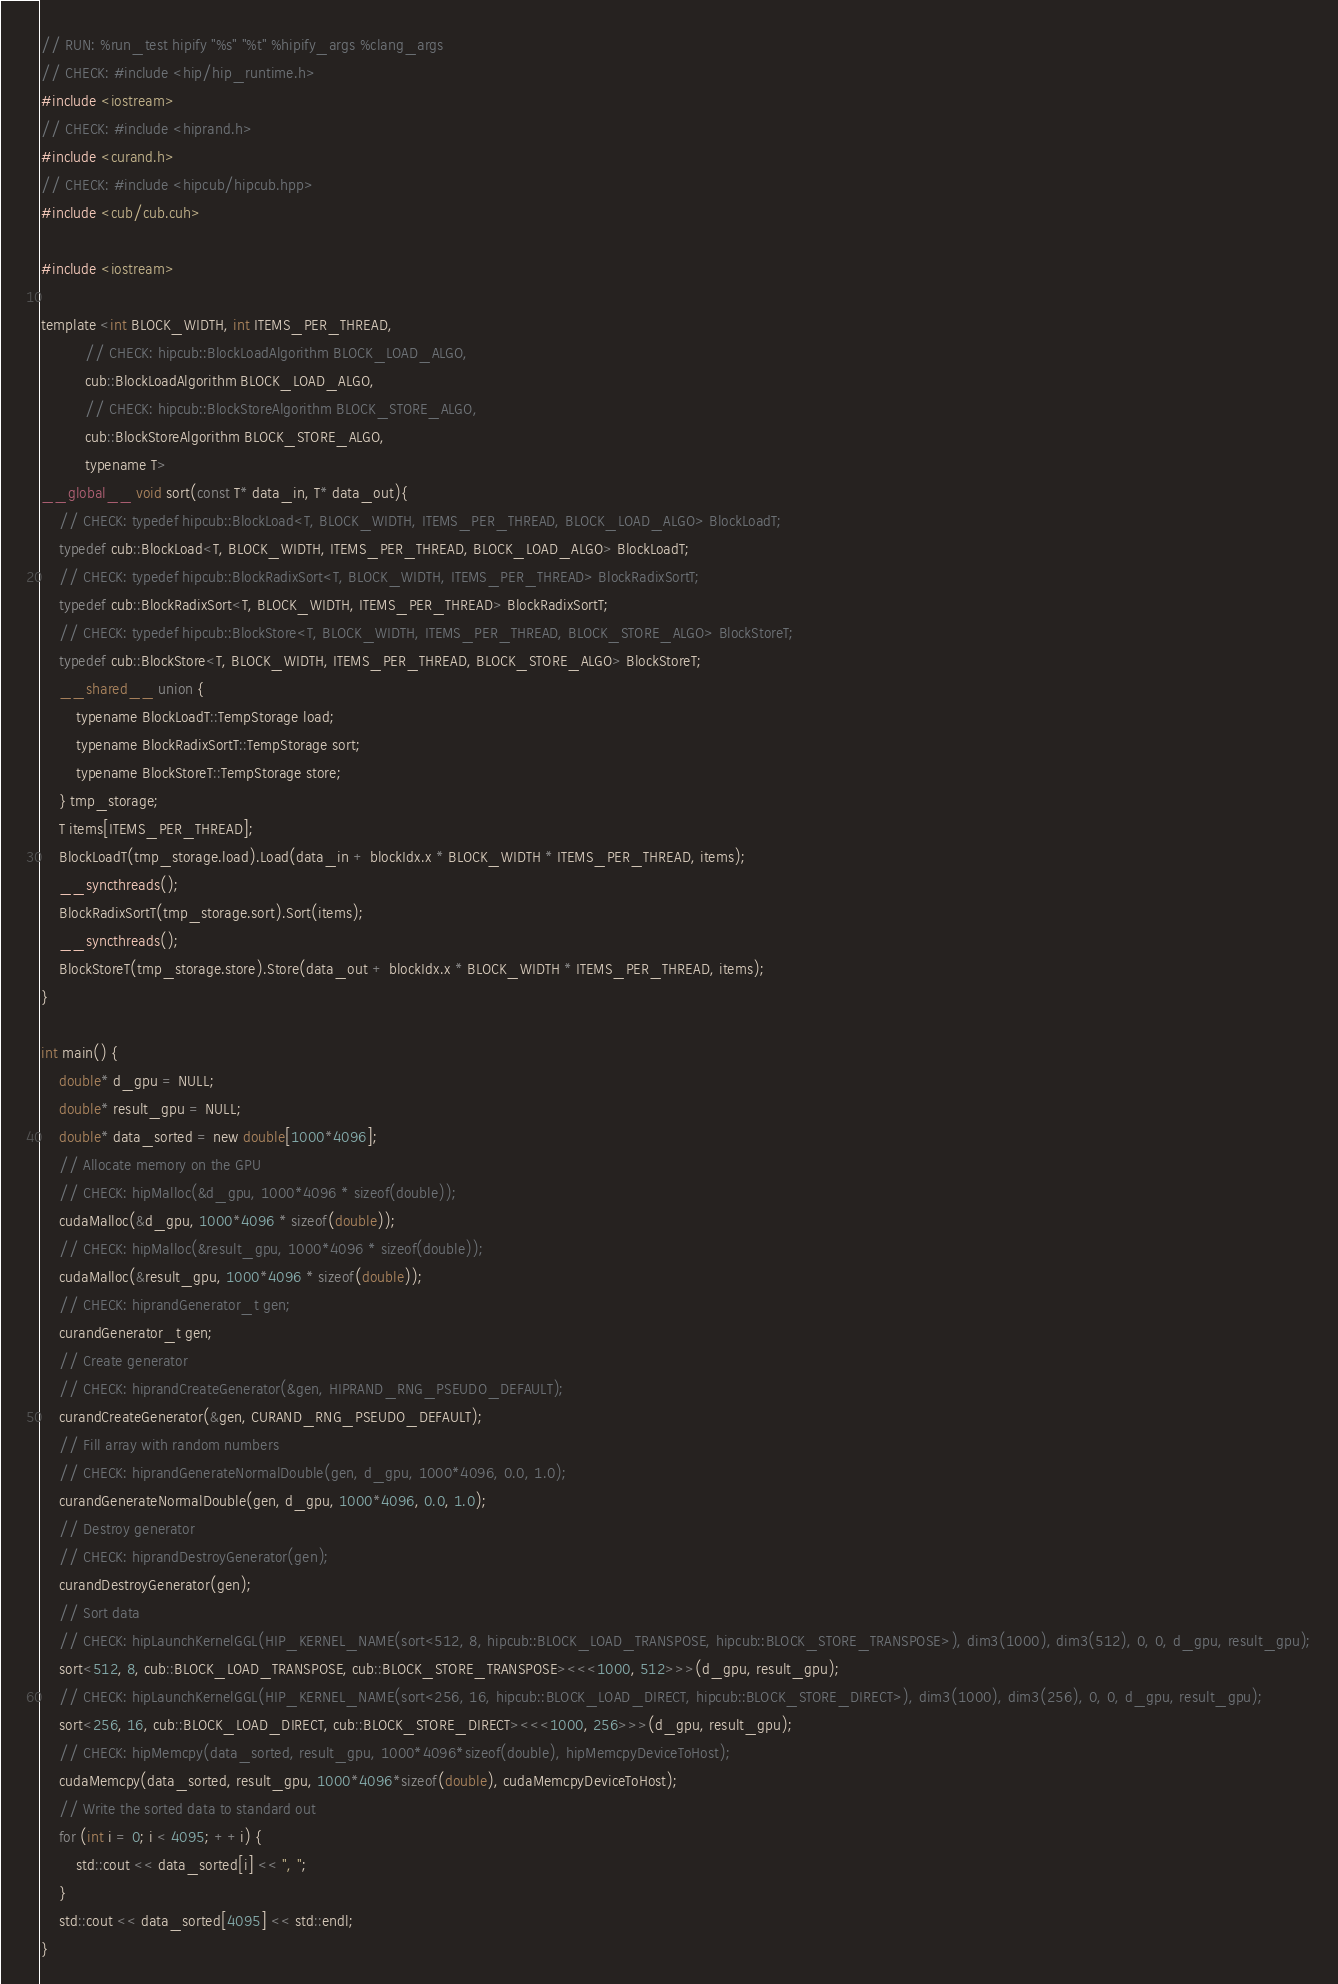<code> <loc_0><loc_0><loc_500><loc_500><_Cuda_>// RUN: %run_test hipify "%s" "%t" %hipify_args %clang_args
// CHECK: #include <hip/hip_runtime.h>
#include <iostream>
// CHECK: #include <hiprand.h>
#include <curand.h>
// CHECK: #include <hipcub/hipcub.hpp>
#include <cub/cub.cuh>

#include <iostream>

template <int BLOCK_WIDTH, int ITEMS_PER_THREAD,
          // CHECK: hipcub::BlockLoadAlgorithm BLOCK_LOAD_ALGO,
          cub::BlockLoadAlgorithm BLOCK_LOAD_ALGO,
          // CHECK: hipcub::BlockStoreAlgorithm BLOCK_STORE_ALGO,
          cub::BlockStoreAlgorithm BLOCK_STORE_ALGO,
          typename T>
__global__ void sort(const T* data_in, T* data_out){
    // CHECK: typedef hipcub::BlockLoad<T, BLOCK_WIDTH, ITEMS_PER_THREAD, BLOCK_LOAD_ALGO> BlockLoadT;
    typedef cub::BlockLoad<T, BLOCK_WIDTH, ITEMS_PER_THREAD, BLOCK_LOAD_ALGO> BlockLoadT;
    // CHECK: typedef hipcub::BlockRadixSort<T, BLOCK_WIDTH, ITEMS_PER_THREAD> BlockRadixSortT;
    typedef cub::BlockRadixSort<T, BLOCK_WIDTH, ITEMS_PER_THREAD> BlockRadixSortT;
    // CHECK: typedef hipcub::BlockStore<T, BLOCK_WIDTH, ITEMS_PER_THREAD, BLOCK_STORE_ALGO> BlockStoreT;
    typedef cub::BlockStore<T, BLOCK_WIDTH, ITEMS_PER_THREAD, BLOCK_STORE_ALGO> BlockStoreT;
    __shared__ union {
        typename BlockLoadT::TempStorage load;
        typename BlockRadixSortT::TempStorage sort;
        typename BlockStoreT::TempStorage store;
    } tmp_storage;
    T items[ITEMS_PER_THREAD];
    BlockLoadT(tmp_storage.load).Load(data_in + blockIdx.x * BLOCK_WIDTH * ITEMS_PER_THREAD, items);
    __syncthreads();
    BlockRadixSortT(tmp_storage.sort).Sort(items);
    __syncthreads();
    BlockStoreT(tmp_storage.store).Store(data_out + blockIdx.x * BLOCK_WIDTH * ITEMS_PER_THREAD, items);
}

int main() {
    double* d_gpu = NULL;
    double* result_gpu = NULL;
    double* data_sorted = new double[1000*4096];
    // Allocate memory on the GPU
    // CHECK: hipMalloc(&d_gpu, 1000*4096 * sizeof(double));
    cudaMalloc(&d_gpu, 1000*4096 * sizeof(double));
    // CHECK: hipMalloc(&result_gpu, 1000*4096 * sizeof(double));
    cudaMalloc(&result_gpu, 1000*4096 * sizeof(double));
    // CHECK: hiprandGenerator_t gen;
    curandGenerator_t gen;
    // Create generator
    // CHECK: hiprandCreateGenerator(&gen, HIPRAND_RNG_PSEUDO_DEFAULT);
    curandCreateGenerator(&gen, CURAND_RNG_PSEUDO_DEFAULT);
    // Fill array with random numbers
    // CHECK: hiprandGenerateNormalDouble(gen, d_gpu, 1000*4096, 0.0, 1.0);
    curandGenerateNormalDouble(gen, d_gpu, 1000*4096, 0.0, 1.0);
    // Destroy generator
    // CHECK: hiprandDestroyGenerator(gen);
    curandDestroyGenerator(gen);
    // Sort data
    // CHECK: hipLaunchKernelGGL(HIP_KERNEL_NAME(sort<512, 8, hipcub::BLOCK_LOAD_TRANSPOSE, hipcub::BLOCK_STORE_TRANSPOSE>), dim3(1000), dim3(512), 0, 0, d_gpu, result_gpu);
    sort<512, 8, cub::BLOCK_LOAD_TRANSPOSE, cub::BLOCK_STORE_TRANSPOSE><<<1000, 512>>>(d_gpu, result_gpu);
    // CHECK: hipLaunchKernelGGL(HIP_KERNEL_NAME(sort<256, 16, hipcub::BLOCK_LOAD_DIRECT, hipcub::BLOCK_STORE_DIRECT>), dim3(1000), dim3(256), 0, 0, d_gpu, result_gpu);
    sort<256, 16, cub::BLOCK_LOAD_DIRECT, cub::BLOCK_STORE_DIRECT><<<1000, 256>>>(d_gpu, result_gpu);
    // CHECK: hipMemcpy(data_sorted, result_gpu, 1000*4096*sizeof(double), hipMemcpyDeviceToHost);
    cudaMemcpy(data_sorted, result_gpu, 1000*4096*sizeof(double), cudaMemcpyDeviceToHost);
    // Write the sorted data to standard out
    for (int i = 0; i < 4095; ++i) {
        std::cout << data_sorted[i] << ", ";
    }
    std::cout << data_sorted[4095] << std::endl;
}
</code> 